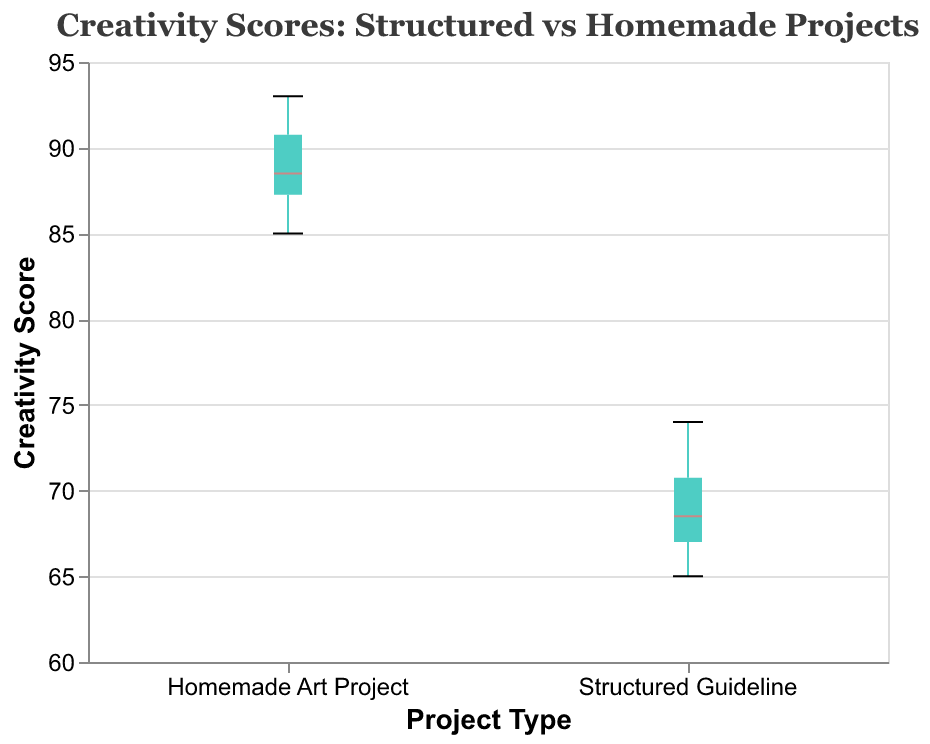What are the titles of the axes? The x-axis title is "Project Type" and the y-axis title is "Creativity Score". These titles help in understanding what each axis represents in the plot.
Answer: "Project Type" and "Creativity Score" What are the two types of projects compared in the plot? The x-axis shows two categories: "Structured Guideline" and "Homemade Art Project", which are the two types of projects being compared.
Answer: "Structured Guideline" and "Homemade Art Project" What is the title of the plot? The plot title is "Creativity Scores: Structured vs Homemade Projects". This title gives an overview of the plot's theme.
Answer: "Creativity Scores: Structured vs Homemade Projects" What is the range of creativity scores for the Homemade Art Project group? The plot's y-axis scale shows that the scores for the Homemade Art Project group range approximately from 85 to 93. Identifying the min and max points on the boxplot tells us the range.
Answer: 85 to 93 Which group has a higher median creativity score? The homemade art project's median is marked in a different color (e.g., #ff6b6b), and it is higher compared to the structured guideline group. Observing the position of the median lines in both groups’ boxplots helps in identifying this.
Answer: Homemade Art Project What is the median creativity score for the Structured Guideline project type? By looking at the median line on the boxplot for the Structured Guideline group, we see it's located around a creativity score of 68.
Answer: 68 What is the range of creativity scores for the Structured Guideline group? The boxplot shows that the Structured Guideline group ranges from a minimum value of 65 to a maximum value of 74 on the y-axis. The entire span of the boxplot provides this range.
Answer: 65 to 74 Which group shows more variability in creativity scores? The range for Homemade Art Project (85 - 93) is smaller compared to the range for Structured Guideline (65 - 74), indicating less variability in the homemade art group. Inspecting the lengths of the boxplots helps identify variability.
Answer: Structured Guideline What is the interquartile range (IQR) of the Homemade Art Project group? The IQR is the range between the first quartile and third quartile. For the Homemade Art Project group, it spans from around 87 (Q1) to 91 (Q3). Calculating the difference gives 91 - 87 = 4.
Answer: 4 What conclusion can be drawn about students' creativity scores between the two project types? Observing the median lines and the ranges, we see that students score higher and show less variability on creativity scores in Homemade Art Projects, implying a positive impact of open-ended projects on creativity. Comparing both groups' boxplots yields this conclusion.
Answer: Homemade Art Projects have higher scores and less variability 